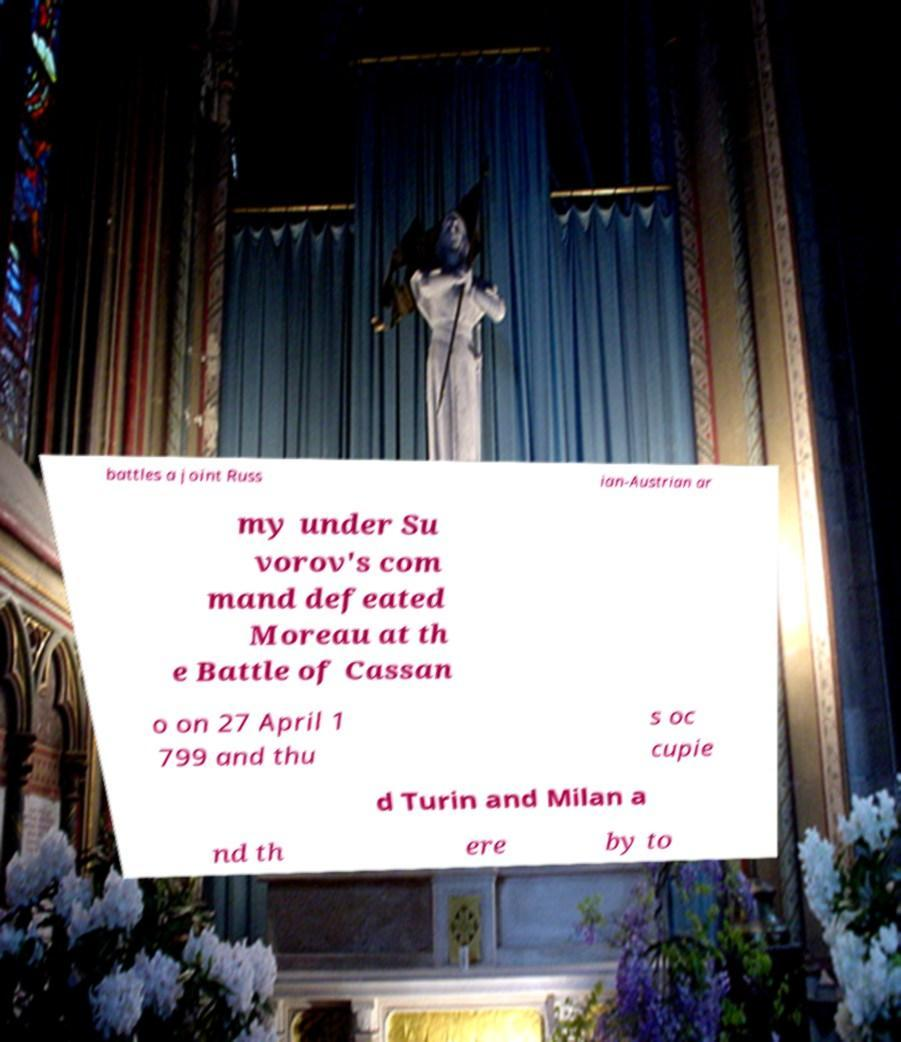There's text embedded in this image that I need extracted. Can you transcribe it verbatim? battles a joint Russ ian-Austrian ar my under Su vorov's com mand defeated Moreau at th e Battle of Cassan o on 27 April 1 799 and thu s oc cupie d Turin and Milan a nd th ere by to 